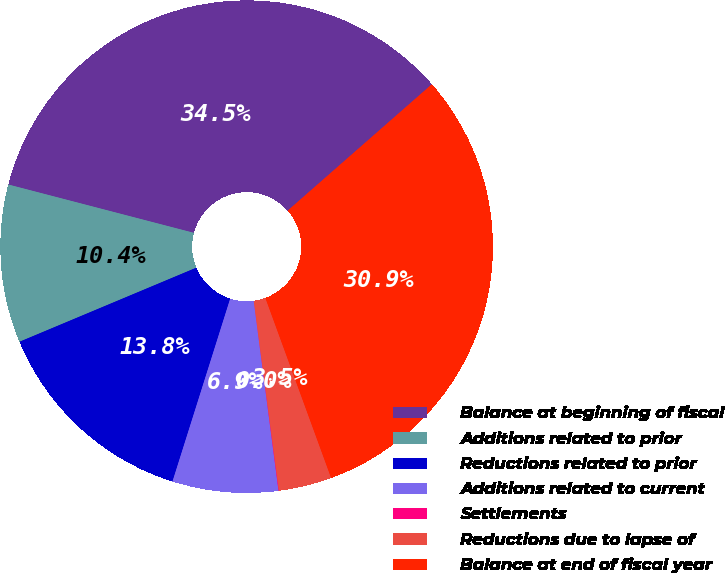<chart> <loc_0><loc_0><loc_500><loc_500><pie_chart><fcel>Balance at beginning of fiscal<fcel>Additions related to prior<fcel>Reductions related to prior<fcel>Additions related to current<fcel>Settlements<fcel>Reductions due to lapse of<fcel>Balance at end of fiscal year<nl><fcel>34.49%<fcel>10.37%<fcel>13.82%<fcel>6.93%<fcel>0.03%<fcel>3.48%<fcel>30.88%<nl></chart> 